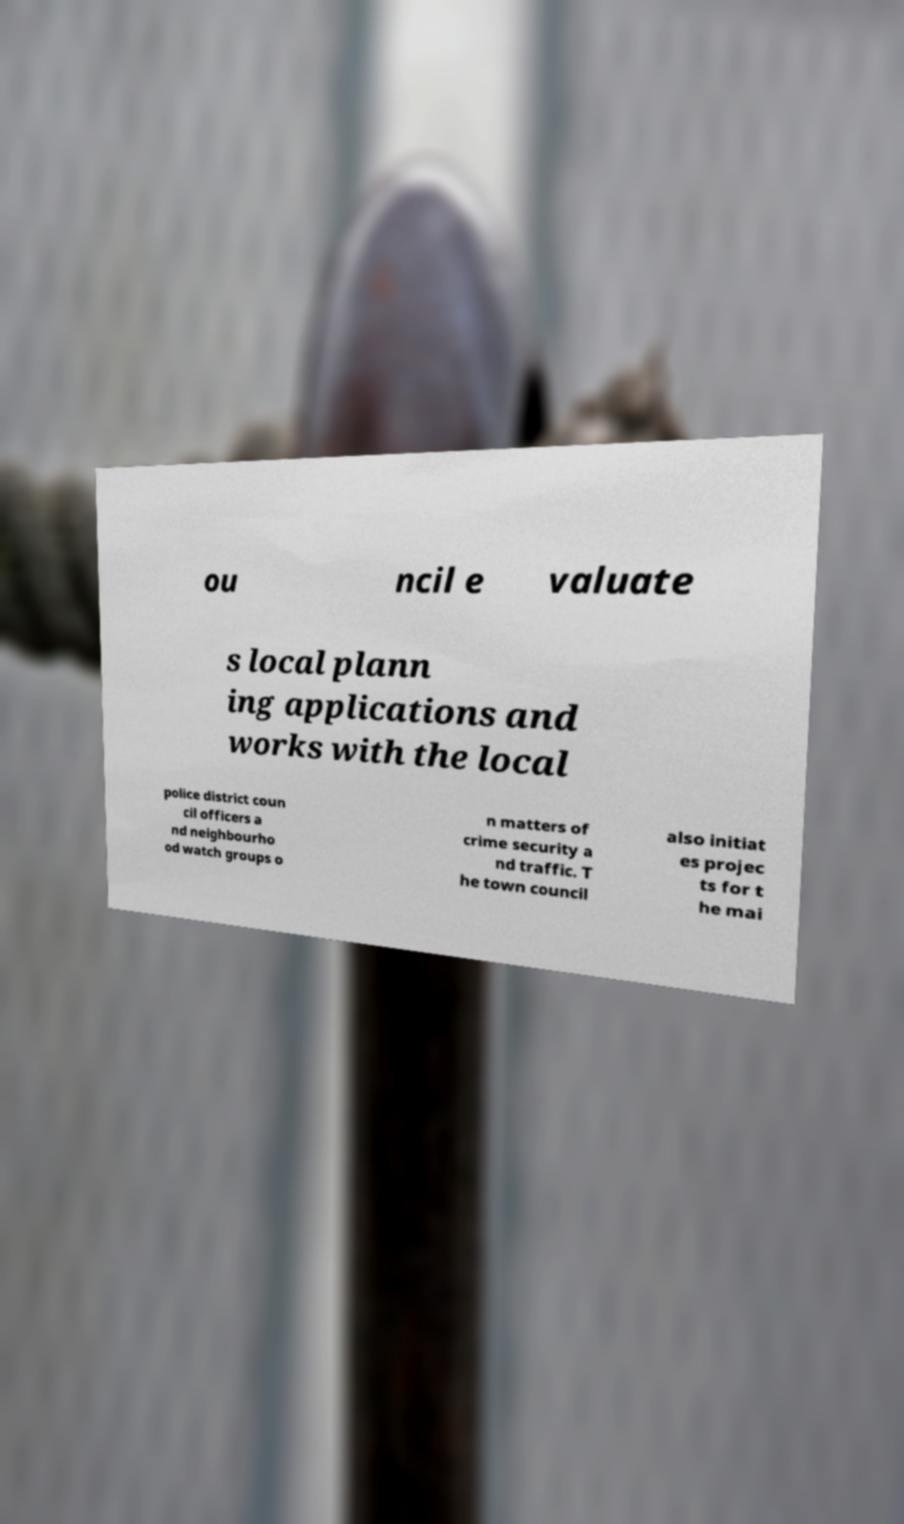What messages or text are displayed in this image? I need them in a readable, typed format. ou ncil e valuate s local plann ing applications and works with the local police district coun cil officers a nd neighbourho od watch groups o n matters of crime security a nd traffic. T he town council also initiat es projec ts for t he mai 